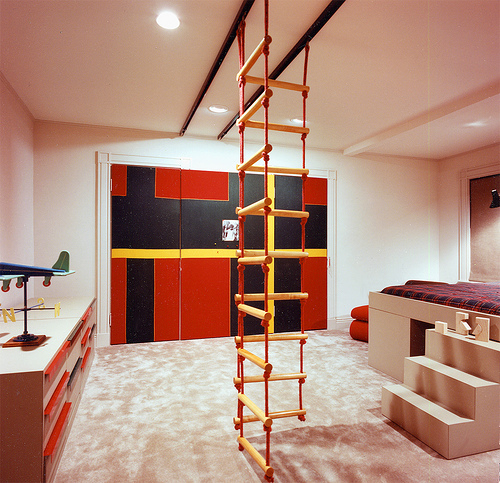Identify the text contained in this image. N 